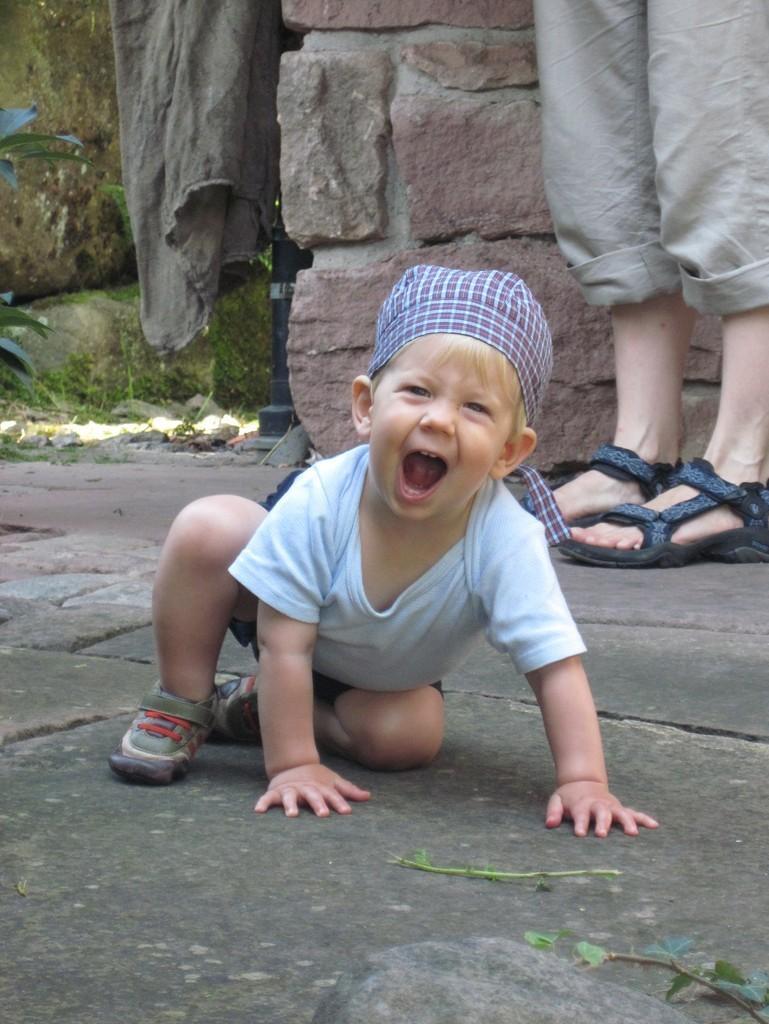In one or two sentences, can you explain what this image depicts? In this picture there is a boy on the surface and we can see person's legs with footwear. In the background of the image we can see wall, leaves, grass and cloth. 